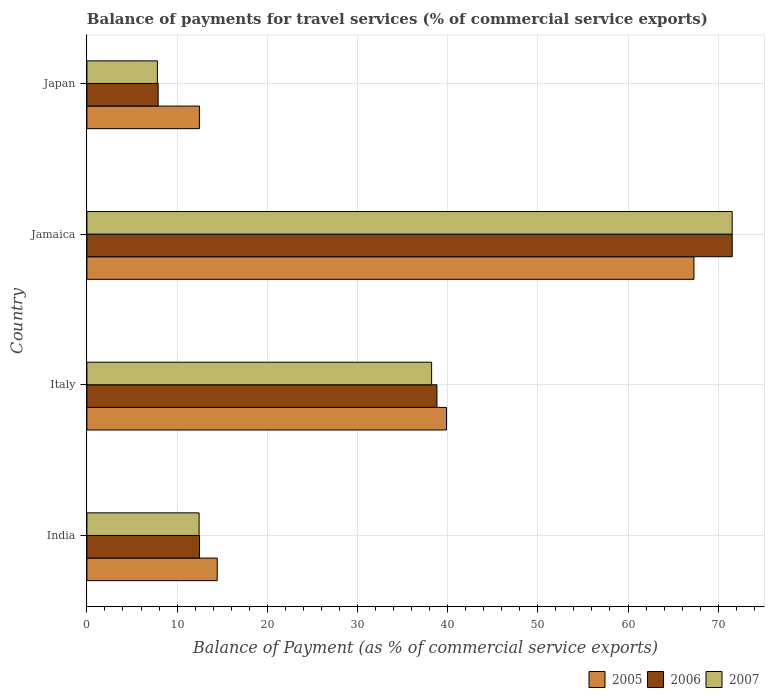How many different coloured bars are there?
Provide a short and direct response. 3. How many groups of bars are there?
Provide a succinct answer. 4. Are the number of bars per tick equal to the number of legend labels?
Keep it short and to the point. Yes. How many bars are there on the 1st tick from the top?
Provide a succinct answer. 3. In how many cases, is the number of bars for a given country not equal to the number of legend labels?
Give a very brief answer. 0. What is the balance of payments for travel services in 2007 in Jamaica?
Make the answer very short. 71.55. Across all countries, what is the maximum balance of payments for travel services in 2006?
Your answer should be compact. 71.55. Across all countries, what is the minimum balance of payments for travel services in 2006?
Give a very brief answer. 7.9. In which country was the balance of payments for travel services in 2007 maximum?
Your response must be concise. Jamaica. What is the total balance of payments for travel services in 2007 in the graph?
Offer a terse response. 130.03. What is the difference between the balance of payments for travel services in 2006 in India and that in Jamaica?
Provide a short and direct response. -59.07. What is the difference between the balance of payments for travel services in 2005 in India and the balance of payments for travel services in 2006 in Japan?
Provide a succinct answer. 6.55. What is the average balance of payments for travel services in 2007 per country?
Give a very brief answer. 32.51. What is the difference between the balance of payments for travel services in 2007 and balance of payments for travel services in 2006 in Japan?
Provide a succinct answer. -0.08. In how many countries, is the balance of payments for travel services in 2005 greater than 50 %?
Offer a terse response. 1. What is the ratio of the balance of payments for travel services in 2007 in India to that in Jamaica?
Your response must be concise. 0.17. Is the balance of payments for travel services in 2007 in India less than that in Japan?
Provide a succinct answer. No. Is the difference between the balance of payments for travel services in 2007 in India and Japan greater than the difference between the balance of payments for travel services in 2006 in India and Japan?
Your answer should be very brief. Yes. What is the difference between the highest and the second highest balance of payments for travel services in 2005?
Make the answer very short. 27.44. What is the difference between the highest and the lowest balance of payments for travel services in 2005?
Provide a short and direct response. 54.83. What does the 3rd bar from the top in India represents?
Offer a very short reply. 2005. What does the 2nd bar from the bottom in Italy represents?
Your answer should be compact. 2006. Are all the bars in the graph horizontal?
Ensure brevity in your answer.  Yes. How many countries are there in the graph?
Provide a succinct answer. 4. Does the graph contain any zero values?
Give a very brief answer. No. Does the graph contain grids?
Ensure brevity in your answer.  Yes. Where does the legend appear in the graph?
Your response must be concise. Bottom right. How are the legend labels stacked?
Ensure brevity in your answer.  Horizontal. What is the title of the graph?
Provide a short and direct response. Balance of payments for travel services (% of commercial service exports). Does "2013" appear as one of the legend labels in the graph?
Provide a short and direct response. No. What is the label or title of the X-axis?
Ensure brevity in your answer.  Balance of Payment (as % of commercial service exports). What is the label or title of the Y-axis?
Offer a very short reply. Country. What is the Balance of Payment (as % of commercial service exports) of 2005 in India?
Ensure brevity in your answer.  14.45. What is the Balance of Payment (as % of commercial service exports) in 2006 in India?
Your response must be concise. 12.48. What is the Balance of Payment (as % of commercial service exports) in 2007 in India?
Provide a short and direct response. 12.44. What is the Balance of Payment (as % of commercial service exports) of 2005 in Italy?
Your answer should be very brief. 39.87. What is the Balance of Payment (as % of commercial service exports) in 2006 in Italy?
Ensure brevity in your answer.  38.81. What is the Balance of Payment (as % of commercial service exports) in 2007 in Italy?
Give a very brief answer. 38.22. What is the Balance of Payment (as % of commercial service exports) of 2005 in Jamaica?
Your answer should be very brief. 67.31. What is the Balance of Payment (as % of commercial service exports) of 2006 in Jamaica?
Make the answer very short. 71.55. What is the Balance of Payment (as % of commercial service exports) of 2007 in Jamaica?
Make the answer very short. 71.55. What is the Balance of Payment (as % of commercial service exports) of 2005 in Japan?
Your response must be concise. 12.48. What is the Balance of Payment (as % of commercial service exports) in 2006 in Japan?
Your answer should be compact. 7.9. What is the Balance of Payment (as % of commercial service exports) of 2007 in Japan?
Give a very brief answer. 7.82. Across all countries, what is the maximum Balance of Payment (as % of commercial service exports) of 2005?
Offer a terse response. 67.31. Across all countries, what is the maximum Balance of Payment (as % of commercial service exports) of 2006?
Provide a short and direct response. 71.55. Across all countries, what is the maximum Balance of Payment (as % of commercial service exports) in 2007?
Give a very brief answer. 71.55. Across all countries, what is the minimum Balance of Payment (as % of commercial service exports) in 2005?
Your answer should be very brief. 12.48. Across all countries, what is the minimum Balance of Payment (as % of commercial service exports) in 2006?
Provide a short and direct response. 7.9. Across all countries, what is the minimum Balance of Payment (as % of commercial service exports) in 2007?
Offer a terse response. 7.82. What is the total Balance of Payment (as % of commercial service exports) of 2005 in the graph?
Your response must be concise. 134.11. What is the total Balance of Payment (as % of commercial service exports) of 2006 in the graph?
Keep it short and to the point. 130.75. What is the total Balance of Payment (as % of commercial service exports) in 2007 in the graph?
Ensure brevity in your answer.  130.03. What is the difference between the Balance of Payment (as % of commercial service exports) in 2005 in India and that in Italy?
Give a very brief answer. -25.42. What is the difference between the Balance of Payment (as % of commercial service exports) in 2006 in India and that in Italy?
Provide a short and direct response. -26.33. What is the difference between the Balance of Payment (as % of commercial service exports) in 2007 in India and that in Italy?
Ensure brevity in your answer.  -25.78. What is the difference between the Balance of Payment (as % of commercial service exports) of 2005 in India and that in Jamaica?
Make the answer very short. -52.86. What is the difference between the Balance of Payment (as % of commercial service exports) of 2006 in India and that in Jamaica?
Your answer should be very brief. -59.07. What is the difference between the Balance of Payment (as % of commercial service exports) in 2007 in India and that in Jamaica?
Provide a succinct answer. -59.11. What is the difference between the Balance of Payment (as % of commercial service exports) of 2005 in India and that in Japan?
Offer a terse response. 1.97. What is the difference between the Balance of Payment (as % of commercial service exports) in 2006 in India and that in Japan?
Ensure brevity in your answer.  4.58. What is the difference between the Balance of Payment (as % of commercial service exports) of 2007 in India and that in Japan?
Provide a short and direct response. 4.62. What is the difference between the Balance of Payment (as % of commercial service exports) in 2005 in Italy and that in Jamaica?
Give a very brief answer. -27.44. What is the difference between the Balance of Payment (as % of commercial service exports) of 2006 in Italy and that in Jamaica?
Offer a terse response. -32.74. What is the difference between the Balance of Payment (as % of commercial service exports) in 2007 in Italy and that in Jamaica?
Your answer should be compact. -33.32. What is the difference between the Balance of Payment (as % of commercial service exports) in 2005 in Italy and that in Japan?
Offer a very short reply. 27.4. What is the difference between the Balance of Payment (as % of commercial service exports) in 2006 in Italy and that in Japan?
Offer a very short reply. 30.91. What is the difference between the Balance of Payment (as % of commercial service exports) in 2007 in Italy and that in Japan?
Make the answer very short. 30.41. What is the difference between the Balance of Payment (as % of commercial service exports) in 2005 in Jamaica and that in Japan?
Offer a terse response. 54.83. What is the difference between the Balance of Payment (as % of commercial service exports) in 2006 in Jamaica and that in Japan?
Your answer should be compact. 63.65. What is the difference between the Balance of Payment (as % of commercial service exports) in 2007 in Jamaica and that in Japan?
Provide a short and direct response. 63.73. What is the difference between the Balance of Payment (as % of commercial service exports) in 2005 in India and the Balance of Payment (as % of commercial service exports) in 2006 in Italy?
Ensure brevity in your answer.  -24.36. What is the difference between the Balance of Payment (as % of commercial service exports) in 2005 in India and the Balance of Payment (as % of commercial service exports) in 2007 in Italy?
Offer a terse response. -23.77. What is the difference between the Balance of Payment (as % of commercial service exports) of 2006 in India and the Balance of Payment (as % of commercial service exports) of 2007 in Italy?
Ensure brevity in your answer.  -25.74. What is the difference between the Balance of Payment (as % of commercial service exports) of 2005 in India and the Balance of Payment (as % of commercial service exports) of 2006 in Jamaica?
Offer a very short reply. -57.1. What is the difference between the Balance of Payment (as % of commercial service exports) in 2005 in India and the Balance of Payment (as % of commercial service exports) in 2007 in Jamaica?
Keep it short and to the point. -57.1. What is the difference between the Balance of Payment (as % of commercial service exports) in 2006 in India and the Balance of Payment (as % of commercial service exports) in 2007 in Jamaica?
Offer a very short reply. -59.07. What is the difference between the Balance of Payment (as % of commercial service exports) in 2005 in India and the Balance of Payment (as % of commercial service exports) in 2006 in Japan?
Provide a short and direct response. 6.55. What is the difference between the Balance of Payment (as % of commercial service exports) in 2005 in India and the Balance of Payment (as % of commercial service exports) in 2007 in Japan?
Ensure brevity in your answer.  6.63. What is the difference between the Balance of Payment (as % of commercial service exports) of 2006 in India and the Balance of Payment (as % of commercial service exports) of 2007 in Japan?
Provide a succinct answer. 4.66. What is the difference between the Balance of Payment (as % of commercial service exports) in 2005 in Italy and the Balance of Payment (as % of commercial service exports) in 2006 in Jamaica?
Offer a terse response. -31.68. What is the difference between the Balance of Payment (as % of commercial service exports) of 2005 in Italy and the Balance of Payment (as % of commercial service exports) of 2007 in Jamaica?
Your answer should be very brief. -31.68. What is the difference between the Balance of Payment (as % of commercial service exports) of 2006 in Italy and the Balance of Payment (as % of commercial service exports) of 2007 in Jamaica?
Provide a succinct answer. -32.73. What is the difference between the Balance of Payment (as % of commercial service exports) in 2005 in Italy and the Balance of Payment (as % of commercial service exports) in 2006 in Japan?
Make the answer very short. 31.97. What is the difference between the Balance of Payment (as % of commercial service exports) in 2005 in Italy and the Balance of Payment (as % of commercial service exports) in 2007 in Japan?
Provide a short and direct response. 32.05. What is the difference between the Balance of Payment (as % of commercial service exports) of 2006 in Italy and the Balance of Payment (as % of commercial service exports) of 2007 in Japan?
Provide a succinct answer. 31. What is the difference between the Balance of Payment (as % of commercial service exports) of 2005 in Jamaica and the Balance of Payment (as % of commercial service exports) of 2006 in Japan?
Make the answer very short. 59.41. What is the difference between the Balance of Payment (as % of commercial service exports) of 2005 in Jamaica and the Balance of Payment (as % of commercial service exports) of 2007 in Japan?
Keep it short and to the point. 59.49. What is the difference between the Balance of Payment (as % of commercial service exports) of 2006 in Jamaica and the Balance of Payment (as % of commercial service exports) of 2007 in Japan?
Ensure brevity in your answer.  63.74. What is the average Balance of Payment (as % of commercial service exports) in 2005 per country?
Offer a very short reply. 33.53. What is the average Balance of Payment (as % of commercial service exports) of 2006 per country?
Your answer should be compact. 32.69. What is the average Balance of Payment (as % of commercial service exports) in 2007 per country?
Provide a succinct answer. 32.51. What is the difference between the Balance of Payment (as % of commercial service exports) of 2005 and Balance of Payment (as % of commercial service exports) of 2006 in India?
Your answer should be compact. 1.97. What is the difference between the Balance of Payment (as % of commercial service exports) in 2005 and Balance of Payment (as % of commercial service exports) in 2007 in India?
Offer a very short reply. 2.01. What is the difference between the Balance of Payment (as % of commercial service exports) of 2006 and Balance of Payment (as % of commercial service exports) of 2007 in India?
Offer a terse response. 0.04. What is the difference between the Balance of Payment (as % of commercial service exports) in 2005 and Balance of Payment (as % of commercial service exports) in 2006 in Italy?
Give a very brief answer. 1.06. What is the difference between the Balance of Payment (as % of commercial service exports) in 2005 and Balance of Payment (as % of commercial service exports) in 2007 in Italy?
Make the answer very short. 1.65. What is the difference between the Balance of Payment (as % of commercial service exports) in 2006 and Balance of Payment (as % of commercial service exports) in 2007 in Italy?
Offer a terse response. 0.59. What is the difference between the Balance of Payment (as % of commercial service exports) in 2005 and Balance of Payment (as % of commercial service exports) in 2006 in Jamaica?
Give a very brief answer. -4.24. What is the difference between the Balance of Payment (as % of commercial service exports) in 2005 and Balance of Payment (as % of commercial service exports) in 2007 in Jamaica?
Offer a very short reply. -4.24. What is the difference between the Balance of Payment (as % of commercial service exports) of 2006 and Balance of Payment (as % of commercial service exports) of 2007 in Jamaica?
Offer a terse response. 0.01. What is the difference between the Balance of Payment (as % of commercial service exports) in 2005 and Balance of Payment (as % of commercial service exports) in 2006 in Japan?
Your answer should be very brief. 4.57. What is the difference between the Balance of Payment (as % of commercial service exports) of 2005 and Balance of Payment (as % of commercial service exports) of 2007 in Japan?
Your answer should be very brief. 4.66. What is the difference between the Balance of Payment (as % of commercial service exports) in 2006 and Balance of Payment (as % of commercial service exports) in 2007 in Japan?
Your answer should be compact. 0.08. What is the ratio of the Balance of Payment (as % of commercial service exports) in 2005 in India to that in Italy?
Your response must be concise. 0.36. What is the ratio of the Balance of Payment (as % of commercial service exports) in 2006 in India to that in Italy?
Offer a very short reply. 0.32. What is the ratio of the Balance of Payment (as % of commercial service exports) in 2007 in India to that in Italy?
Your response must be concise. 0.33. What is the ratio of the Balance of Payment (as % of commercial service exports) of 2005 in India to that in Jamaica?
Provide a short and direct response. 0.21. What is the ratio of the Balance of Payment (as % of commercial service exports) of 2006 in India to that in Jamaica?
Provide a succinct answer. 0.17. What is the ratio of the Balance of Payment (as % of commercial service exports) in 2007 in India to that in Jamaica?
Offer a terse response. 0.17. What is the ratio of the Balance of Payment (as % of commercial service exports) of 2005 in India to that in Japan?
Make the answer very short. 1.16. What is the ratio of the Balance of Payment (as % of commercial service exports) in 2006 in India to that in Japan?
Your answer should be compact. 1.58. What is the ratio of the Balance of Payment (as % of commercial service exports) in 2007 in India to that in Japan?
Your answer should be very brief. 1.59. What is the ratio of the Balance of Payment (as % of commercial service exports) of 2005 in Italy to that in Jamaica?
Provide a short and direct response. 0.59. What is the ratio of the Balance of Payment (as % of commercial service exports) in 2006 in Italy to that in Jamaica?
Your answer should be very brief. 0.54. What is the ratio of the Balance of Payment (as % of commercial service exports) of 2007 in Italy to that in Jamaica?
Make the answer very short. 0.53. What is the ratio of the Balance of Payment (as % of commercial service exports) of 2005 in Italy to that in Japan?
Provide a short and direct response. 3.2. What is the ratio of the Balance of Payment (as % of commercial service exports) in 2006 in Italy to that in Japan?
Your answer should be compact. 4.91. What is the ratio of the Balance of Payment (as % of commercial service exports) in 2007 in Italy to that in Japan?
Provide a short and direct response. 4.89. What is the ratio of the Balance of Payment (as % of commercial service exports) of 2005 in Jamaica to that in Japan?
Keep it short and to the point. 5.39. What is the ratio of the Balance of Payment (as % of commercial service exports) in 2006 in Jamaica to that in Japan?
Provide a succinct answer. 9.05. What is the ratio of the Balance of Payment (as % of commercial service exports) in 2007 in Jamaica to that in Japan?
Your answer should be compact. 9.15. What is the difference between the highest and the second highest Balance of Payment (as % of commercial service exports) in 2005?
Offer a terse response. 27.44. What is the difference between the highest and the second highest Balance of Payment (as % of commercial service exports) of 2006?
Keep it short and to the point. 32.74. What is the difference between the highest and the second highest Balance of Payment (as % of commercial service exports) of 2007?
Your answer should be very brief. 33.32. What is the difference between the highest and the lowest Balance of Payment (as % of commercial service exports) in 2005?
Your response must be concise. 54.83. What is the difference between the highest and the lowest Balance of Payment (as % of commercial service exports) of 2006?
Make the answer very short. 63.65. What is the difference between the highest and the lowest Balance of Payment (as % of commercial service exports) of 2007?
Your answer should be compact. 63.73. 